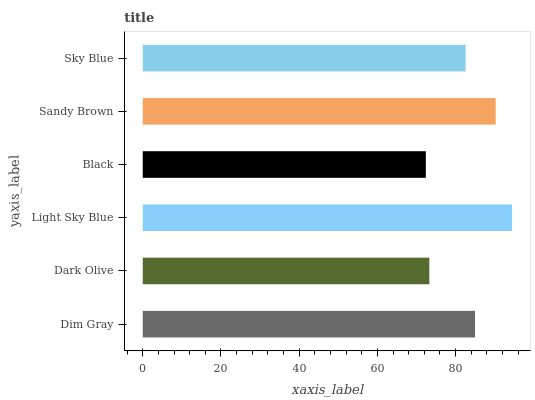Is Black the minimum?
Answer yes or no. Yes. Is Light Sky Blue the maximum?
Answer yes or no. Yes. Is Dark Olive the minimum?
Answer yes or no. No. Is Dark Olive the maximum?
Answer yes or no. No. Is Dim Gray greater than Dark Olive?
Answer yes or no. Yes. Is Dark Olive less than Dim Gray?
Answer yes or no. Yes. Is Dark Olive greater than Dim Gray?
Answer yes or no. No. Is Dim Gray less than Dark Olive?
Answer yes or no. No. Is Dim Gray the high median?
Answer yes or no. Yes. Is Sky Blue the low median?
Answer yes or no. Yes. Is Dark Olive the high median?
Answer yes or no. No. Is Black the low median?
Answer yes or no. No. 